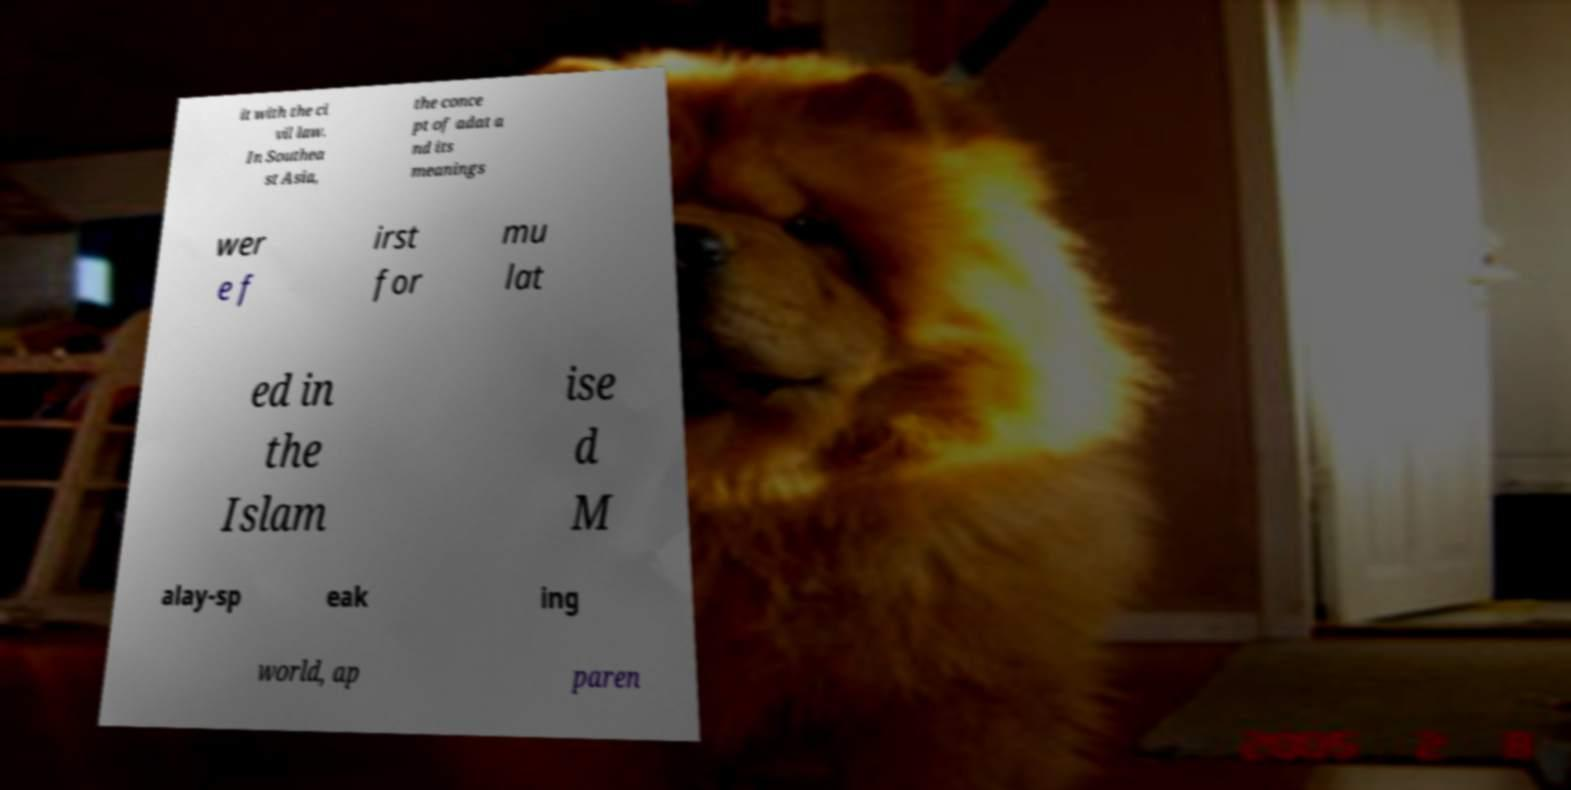For documentation purposes, I need the text within this image transcribed. Could you provide that? it with the ci vil law. In Southea st Asia, the conce pt of adat a nd its meanings wer e f irst for mu lat ed in the Islam ise d M alay-sp eak ing world, ap paren 